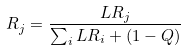Convert formula to latex. <formula><loc_0><loc_0><loc_500><loc_500>R _ { j } = \frac { L R _ { j } } { \sum _ { i } L R _ { i } + ( 1 - Q ) }</formula> 